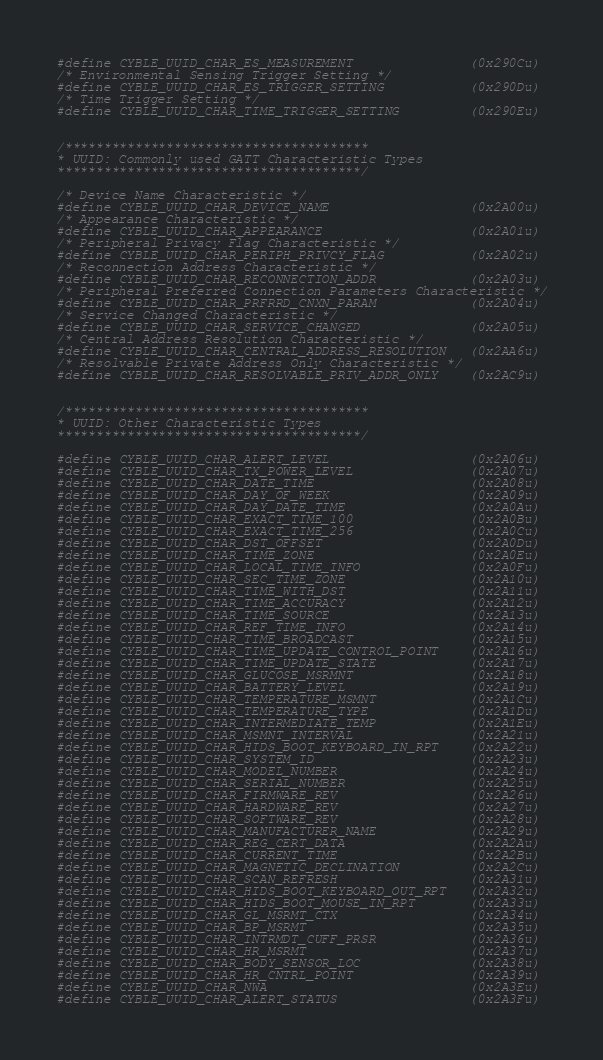<code> <loc_0><loc_0><loc_500><loc_500><_C_>#define CYBLE_UUID_CHAR_ES_MEASUREMENT               (0x290Cu)
/* Environmental Sensing Trigger Setting */
#define CYBLE_UUID_CHAR_ES_TRIGGER_SETTING           (0x290Du)
/* Time Trigger Setting */
#define CYBLE_UUID_CHAR_TIME_TRIGGER_SETTING         (0x290Eu)


/***************************************
* UUID: Commonly used GATT Characteristic Types
***************************************/

/* Device Name Characteristic */
#define CYBLE_UUID_CHAR_DEVICE_NAME                  (0x2A00u)
/* Appearance Characteristic */
#define CYBLE_UUID_CHAR_APPEARANCE                   (0x2A01u)
/* Peripheral Privacy Flag Characteristic */
#define CYBLE_UUID_CHAR_PERIPH_PRIVCY_FLAG           (0x2A02u)
/* Reconnection Address Characteristic */
#define CYBLE_UUID_CHAR_RECONNECTION_ADDR            (0x2A03u)
/* Peripheral Preferred Connection Parameters Characteristic */
#define CYBLE_UUID_CHAR_PRFRRD_CNXN_PARAM            (0x2A04u)
/* Service Changed Characteristic */
#define CYBLE_UUID_CHAR_SERVICE_CHANGED              (0x2A05u)
/* Central Address Resolution Characteristic */
#define CYBLE_UUID_CHAR_CENTRAL_ADDRESS_RESOLUTION   (0x2AA6u)
/* Resolvable Private Address Only Characteristic */
#define CYBLE_UUID_CHAR_RESOLVABLE_PRIV_ADDR_ONLY    (0x2AC9u)


/***************************************
* UUID: Other Characteristic Types
***************************************/

#define CYBLE_UUID_CHAR_ALERT_LEVEL                  (0x2A06u)
#define CYBLE_UUID_CHAR_TX_POWER_LEVEL               (0x2A07u)
#define CYBLE_UUID_CHAR_DATE_TIME                    (0x2A08u)
#define CYBLE_UUID_CHAR_DAY_OF_WEEK                  (0x2A09u)
#define CYBLE_UUID_CHAR_DAY_DATE_TIME                (0x2A0Au)
#define CYBLE_UUID_CHAR_EXACT_TIME_100               (0x2A0Bu)
#define CYBLE_UUID_CHAR_EXACT_TIME_256               (0x2A0Cu)
#define CYBLE_UUID_CHAR_DST_OFFSET                   (0x2A0Du)
#define CYBLE_UUID_CHAR_TIME_ZONE                    (0x2A0Eu)
#define CYBLE_UUID_CHAR_LOCAL_TIME_INFO              (0x2A0Fu)
#define CYBLE_UUID_CHAR_SEC_TIME_ZONE                (0x2A10u)
#define CYBLE_UUID_CHAR_TIME_WITH_DST                (0x2A11u)
#define CYBLE_UUID_CHAR_TIME_ACCURACY                (0x2A12u)
#define CYBLE_UUID_CHAR_TIME_SOURCE                  (0x2A13u)
#define CYBLE_UUID_CHAR_REF_TIME_INFO                (0x2A14u)
#define CYBLE_UUID_CHAR_TIME_BROADCAST               (0x2A15u)
#define CYBLE_UUID_CHAR_TIME_UPDATE_CONTROL_POINT    (0x2A16u)
#define CYBLE_UUID_CHAR_TIME_UPDATE_STATE            (0x2A17u)
#define CYBLE_UUID_CHAR_GLUCOSE_MSRMNT               (0x2A18u)
#define CYBLE_UUID_CHAR_BATTERY_LEVEL                (0x2A19u)
#define CYBLE_UUID_CHAR_TEMPERATURE_MSMNT            (0x2A1Cu)
#define CYBLE_UUID_CHAR_TEMPERATURE_TYPE             (0x2A1Du)
#define CYBLE_UUID_CHAR_INTERMEDIATE_TEMP            (0x2A1Eu)
#define CYBLE_UUID_CHAR_MSMNT_INTERVAL               (0x2A21u)
#define CYBLE_UUID_CHAR_HIDS_BOOT_KEYBOARD_IN_RPT    (0x2A22u)
#define CYBLE_UUID_CHAR_SYSTEM_ID                    (0x2A23u)
#define CYBLE_UUID_CHAR_MODEL_NUMBER                 (0x2A24u)
#define CYBLE_UUID_CHAR_SERIAL_NUMBER                (0x2A25u)
#define CYBLE_UUID_CHAR_FIRMWARE_REV                 (0x2A26u)
#define CYBLE_UUID_CHAR_HARDWARE_REV                 (0x2A27u)
#define CYBLE_UUID_CHAR_SOFTWARE_REV                 (0x2A28u)
#define CYBLE_UUID_CHAR_MANUFACTURER_NAME            (0x2A29u)
#define CYBLE_UUID_CHAR_REG_CERT_DATA                (0x2A2Au)
#define CYBLE_UUID_CHAR_CURRENT_TIME                 (0x2A2Bu)
#define CYBLE_UUID_CHAR_MAGNETIC_DECLINATION         (0x2A2Cu)
#define CYBLE_UUID_CHAR_SCAN_REFRESH                 (0x2A31u)
#define CYBLE_UUID_CHAR_HIDS_BOOT_KEYBOARD_OUT_RPT   (0x2A32u)
#define CYBLE_UUID_CHAR_HIDS_BOOT_MOUSE_IN_RPT       (0x2A33u)
#define CYBLE_UUID_CHAR_GL_MSRMT_CTX                 (0x2A34u)
#define CYBLE_UUID_CHAR_BP_MSRMT                     (0x2A35u)
#define CYBLE_UUID_CHAR_INTRMDT_CUFF_PRSR            (0x2A36u)
#define CYBLE_UUID_CHAR_HR_MSRMT                     (0x2A37u)
#define CYBLE_UUID_CHAR_BODY_SENSOR_LOC              (0x2A38u)
#define CYBLE_UUID_CHAR_HR_CNTRL_POINT               (0x2A39u)
#define CYBLE_UUID_CHAR_NWA                          (0x2A3Eu)
#define CYBLE_UUID_CHAR_ALERT_STATUS                 (0x2A3Fu)</code> 